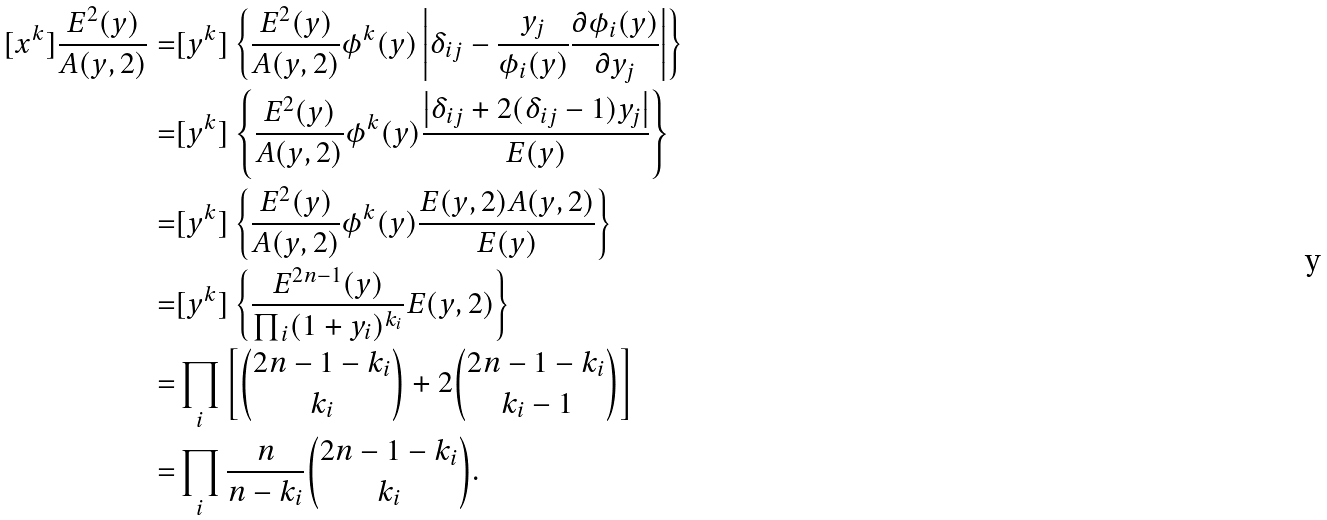<formula> <loc_0><loc_0><loc_500><loc_500>[ x ^ { k } ] \frac { E ^ { 2 } ( y ) } { A ( y , 2 ) } = & [ y ^ { k } ] \left \{ \frac { E ^ { 2 } ( y ) } { A ( y , 2 ) } \phi ^ { k } ( y ) \left | \delta _ { i j } - \frac { y _ { j } } { \phi _ { i } ( y ) } \frac { \partial \phi _ { i } ( y ) } { \partial y _ { j } } \right | \right \} \\ = & [ y ^ { k } ] \left \{ \frac { E ^ { 2 } ( y ) } { A ( y , 2 ) } \phi ^ { k } ( y ) \frac { \left | \delta _ { i j } + 2 ( \delta _ { i j } - 1 ) y _ { j } \right | } { E ( y ) } \right \} \\ = & [ y ^ { k } ] \left \{ \frac { E ^ { 2 } ( y ) } { A ( y , 2 ) } \phi ^ { k } ( y ) \frac { E ( y , 2 ) A ( y , 2 ) } { E ( y ) } \right \} \\ = & [ y ^ { k } ] \left \{ \frac { E ^ { 2 n - 1 } ( y ) } { \prod _ { i } ( 1 + y _ { i } ) ^ { k _ { i } } } E ( y , 2 ) \right \} \\ = & \prod _ { i } \left [ \binom { 2 n - 1 - k _ { i } } { k _ { i } } + 2 \binom { 2 n - 1 - k _ { i } } { k _ { i } - 1 } \right ] \\ = & \prod _ { i } \frac { n } { n - k _ { i } } \binom { 2 n - 1 - k _ { i } } { k _ { i } } .</formula> 